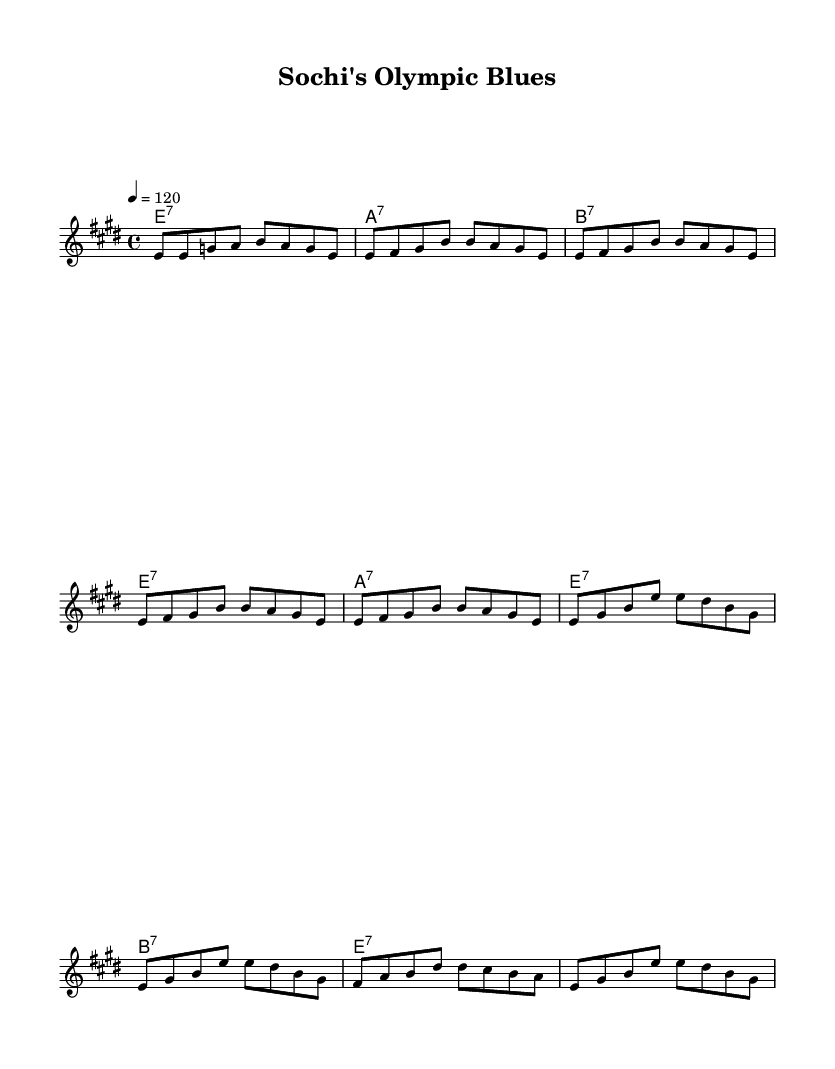What is the key signature of this music? The key signature is E major, which contains four sharps (F#, C#, G#, and D#). This information can be determined from the "global" section where the key is defined.
Answer: E major What is the time signature of this music? The time signature is 4/4, which means there are four beats in each measure and the quarter note gets one beat. This is indicated in the "global" section of the score.
Answer: 4/4 What is the tempo marking for this song? The tempo marking is 120 beats per minute, which can be found in the "global" section where the tempo is explicitly defined using 'tempo 4 = 120'.
Answer: 120 How many verses does the song contain? The song contains four verses. This can be assessed by counting the number of times the 'melodyVerse' is repeated in the score and the number of lines in 'verseWords'.
Answer: Four What is the primary theme of the lyrics? The primary theme of the lyrics is the transformation of Sochi for the Winter Olympics, reflecting on the changes in the city. This theme is derived from the words written in the verses focusing on development and hopes for growth.
Answer: Transformation Identify the chord progression in the verse. The chord progression in the verse follows E7, A7, B7, E7; these chords are indicated in the 'chordNamesVerse' section and show the pattern used throughout the verses.
Answer: E7, A7, B7, E7 What element makes this song an "Electric Blues"? The song incorporates a typical 12-bar blues structure with a focus on emotional expression through its lyrics and rhythm, which are characteristic of the Electric Blues genre. This can be derived from its lyrical content and chord structure focusing on themes of struggle and transformation.
Answer: Emotion 